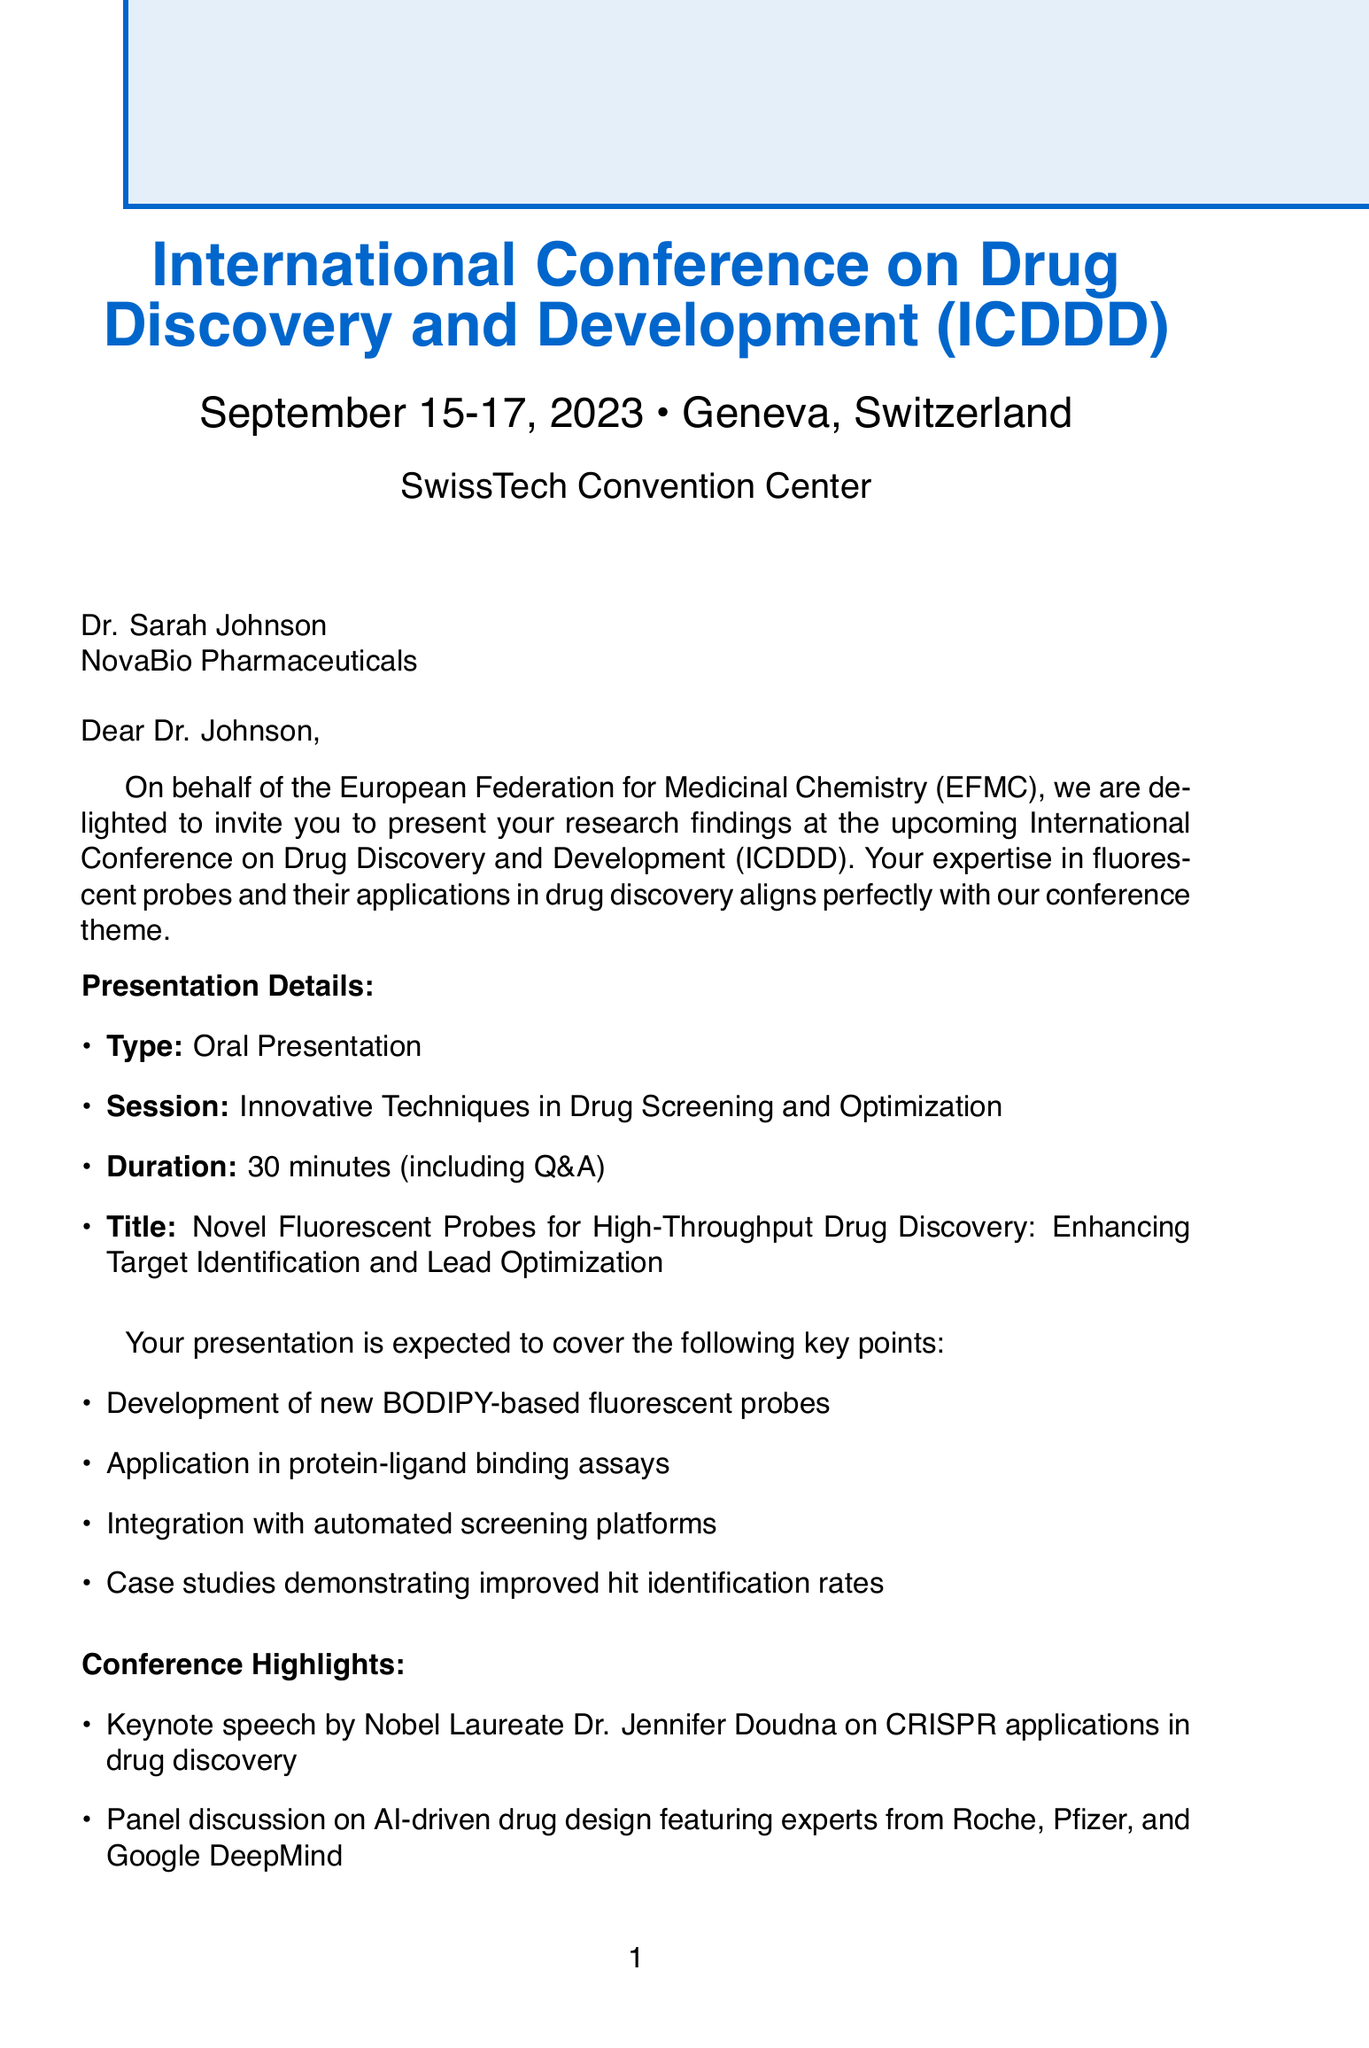What is the name of the conference? The conference's name is mentioned at the top of the document as the International Conference on Drug Discovery and Development (ICDDD).
Answer: International Conference on Drug Discovery and Development (ICDDD) Who is invited to present? The document addresses Dr. Sarah Johnson, indicating she is the invitee for the presentation.
Answer: Dr. Sarah Johnson What is the location of the conference? The document states that the conference will take place in Geneva, Switzerland.
Answer: Geneva, Switzerland What is the presentation type? The document specifies that the presentation type is an Oral Presentation.
Answer: Oral Presentation What is the duration of the presentation? The document states the presentation is expected to last 30 minutes, including Q&A.
Answer: 30 minutes What are the key points of the presentation? The document lists several key points regarding the presentation, including development of new fluorescent probes and their applications.
Answer: Development of new BODIPY-based fluorescent probes What is the registration fee for invited speakers? According to the document, the registration fee for invited speakers is waived.
Answer: Waived Who is the contact person for further information? The document provides the name of the contact person as Dr. Elena Martínez.
Answer: Dr. Elena Martínez What is the nearest airport to the conference venue? The document mentions Geneva Airport (GVA) as the nearest airport to the SwissTech Convention Center.
Answer: Geneva Airport (GVA) 